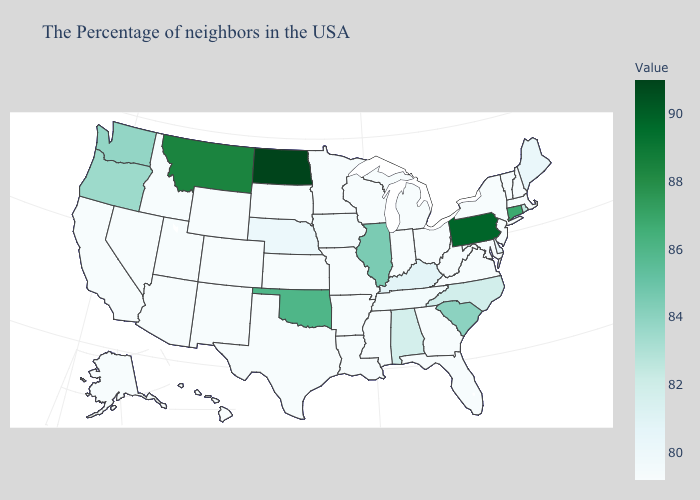Which states have the lowest value in the USA?
Short answer required. Massachusetts, New Hampshire, Vermont, New York, New Jersey, Maryland, Virginia, West Virginia, Ohio, Florida, Georgia, Michigan, Indiana, Wisconsin, Mississippi, Louisiana, Missouri, Arkansas, Minnesota, Kansas, Texas, South Dakota, Wyoming, Colorado, New Mexico, Utah, Arizona, Idaho, Nevada, California, Alaska, Hawaii. Does California have the highest value in the USA?
Answer briefly. No. Does Montana have the highest value in the West?
Write a very short answer. Yes. Is the legend a continuous bar?
Quick response, please. Yes. Which states have the highest value in the USA?
Keep it brief. North Dakota. 